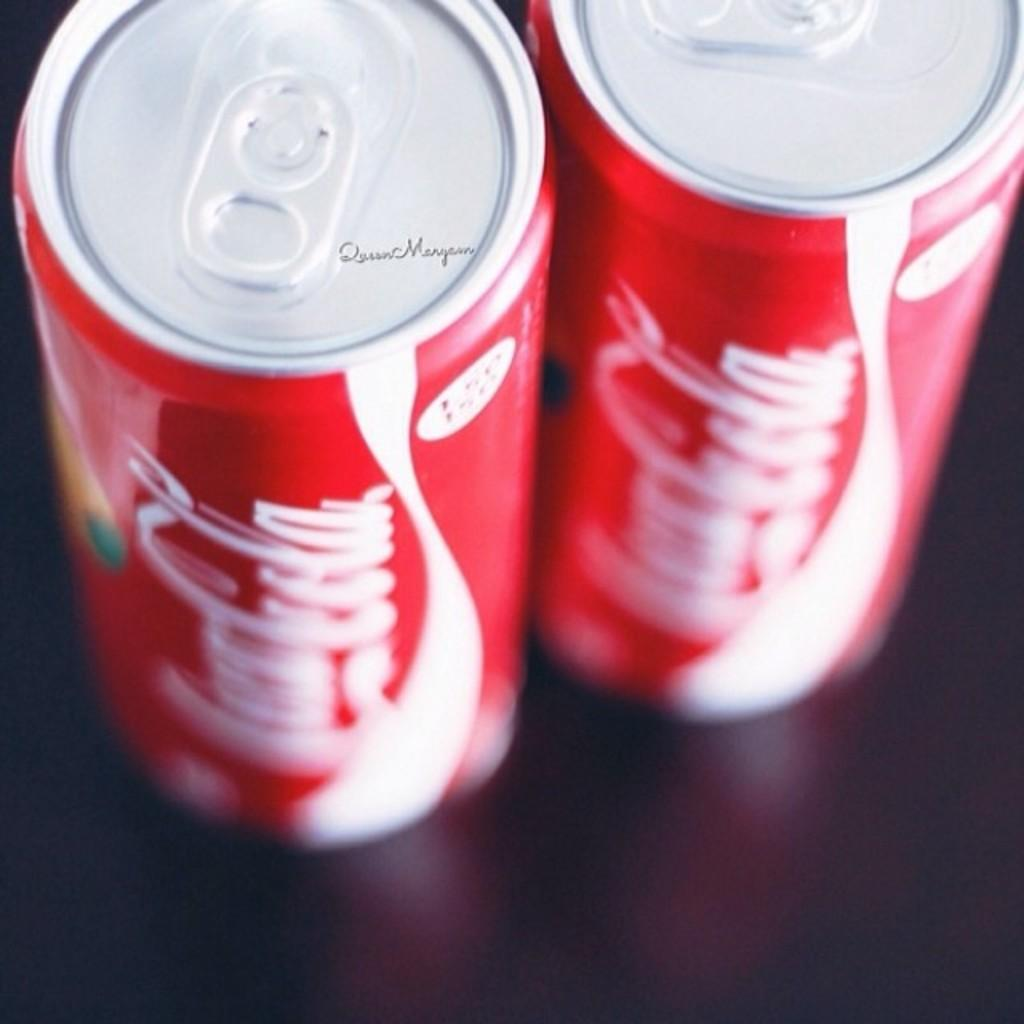<image>
Give a short and clear explanation of the subsequent image. A view looking down to two cans of Coca Cola brand coke sitting on a table. 